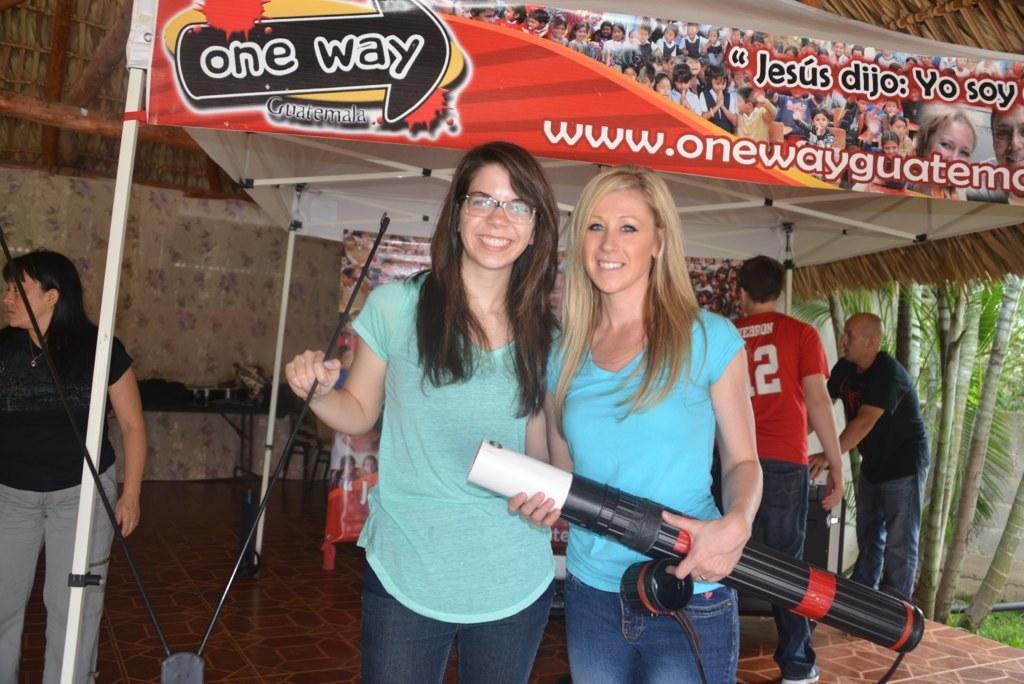Can you describe this image briefly? In this picture there are two girls in the center of the image, there are other people on the right side of the image, there is a stall in the background area of the image, there are trees on the right side of the image, there is another lady on the left side of the image. 